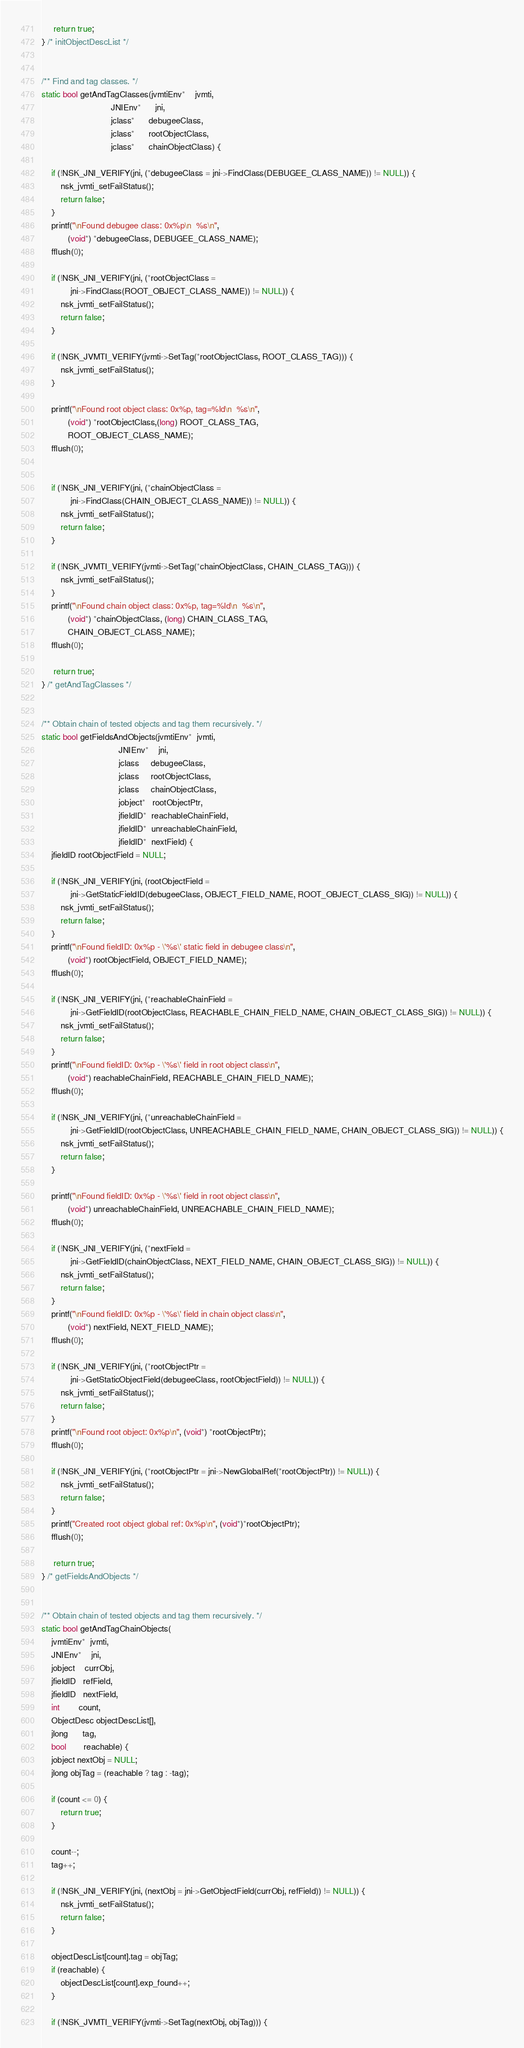Convert code to text. <code><loc_0><loc_0><loc_500><loc_500><_C++_>     return true;
} /* initObjectDescList */


/** Find and tag classes. */
static bool getAndTagClasses(jvmtiEnv*    jvmti,
                             JNIEnv*      jni,
                             jclass*      debugeeClass,
                             jclass*      rootObjectClass,
                             jclass*      chainObjectClass) {

    if (!NSK_JNI_VERIFY(jni, (*debugeeClass = jni->FindClass(DEBUGEE_CLASS_NAME)) != NULL)) {
        nsk_jvmti_setFailStatus();
        return false;
    }
    printf("\nFound debugee class: 0x%p\n  %s\n",
           (void*) *debugeeClass, DEBUGEE_CLASS_NAME);
    fflush(0);

    if (!NSK_JNI_VERIFY(jni, (*rootObjectClass =
            jni->FindClass(ROOT_OBJECT_CLASS_NAME)) != NULL)) {
        nsk_jvmti_setFailStatus();
        return false;
    }

    if (!NSK_JVMTI_VERIFY(jvmti->SetTag(*rootObjectClass, ROOT_CLASS_TAG))) {
        nsk_jvmti_setFailStatus();
    }

    printf("\nFound root object class: 0x%p, tag=%ld\n  %s\n",
           (void*) *rootObjectClass,(long) ROOT_CLASS_TAG,
           ROOT_OBJECT_CLASS_NAME);
    fflush(0);


    if (!NSK_JNI_VERIFY(jni, (*chainObjectClass =
            jni->FindClass(CHAIN_OBJECT_CLASS_NAME)) != NULL)) {
        nsk_jvmti_setFailStatus();
        return false;
    }

    if (!NSK_JVMTI_VERIFY(jvmti->SetTag(*chainObjectClass, CHAIN_CLASS_TAG))) {
        nsk_jvmti_setFailStatus();
    }
    printf("\nFound chain object class: 0x%p, tag=%ld\n  %s\n",
           (void*) *chainObjectClass, (long) CHAIN_CLASS_TAG,
           CHAIN_OBJECT_CLASS_NAME);
    fflush(0);

     return true;
} /* getAndTagClasses */


/** Obtain chain of tested objects and tag them recursively. */
static bool getFieldsAndObjects(jvmtiEnv*  jvmti,
                                JNIEnv*    jni,
                                jclass     debugeeClass,
                                jclass     rootObjectClass,
                                jclass     chainObjectClass,
                                jobject*   rootObjectPtr,
                                jfieldID*  reachableChainField,
                                jfieldID*  unreachableChainField,
                                jfieldID*  nextField) {
    jfieldID rootObjectField = NULL;

    if (!NSK_JNI_VERIFY(jni, (rootObjectField =
            jni->GetStaticFieldID(debugeeClass, OBJECT_FIELD_NAME, ROOT_OBJECT_CLASS_SIG)) != NULL)) {
        nsk_jvmti_setFailStatus();
        return false;
    }
    printf("\nFound fieldID: 0x%p - \'%s\' static field in debugee class\n",
           (void*) rootObjectField, OBJECT_FIELD_NAME);
    fflush(0);

    if (!NSK_JNI_VERIFY(jni, (*reachableChainField =
            jni->GetFieldID(rootObjectClass, REACHABLE_CHAIN_FIELD_NAME, CHAIN_OBJECT_CLASS_SIG)) != NULL)) {
        nsk_jvmti_setFailStatus();
        return false;
    }
    printf("\nFound fieldID: 0x%p - \'%s\' field in root object class\n",
           (void*) reachableChainField, REACHABLE_CHAIN_FIELD_NAME);
    fflush(0);

    if (!NSK_JNI_VERIFY(jni, (*unreachableChainField =
            jni->GetFieldID(rootObjectClass, UNREACHABLE_CHAIN_FIELD_NAME, CHAIN_OBJECT_CLASS_SIG)) != NULL)) {
        nsk_jvmti_setFailStatus();
        return false;
    }

    printf("\nFound fieldID: 0x%p - \'%s\' field in root object class\n",
           (void*) unreachableChainField, UNREACHABLE_CHAIN_FIELD_NAME);
    fflush(0);

    if (!NSK_JNI_VERIFY(jni, (*nextField =
            jni->GetFieldID(chainObjectClass, NEXT_FIELD_NAME, CHAIN_OBJECT_CLASS_SIG)) != NULL)) {
        nsk_jvmti_setFailStatus();
        return false;
    }
    printf("\nFound fieldID: 0x%p - \'%s\' field in chain object class\n",
           (void*) nextField, NEXT_FIELD_NAME);
    fflush(0);

    if (!NSK_JNI_VERIFY(jni, (*rootObjectPtr =
            jni->GetStaticObjectField(debugeeClass, rootObjectField)) != NULL)) {
        nsk_jvmti_setFailStatus();
        return false;
    }
    printf("\nFound root object: 0x%p\n", (void*) *rootObjectPtr);
    fflush(0);

    if (!NSK_JNI_VERIFY(jni, (*rootObjectPtr = jni->NewGlobalRef(*rootObjectPtr)) != NULL)) {
        nsk_jvmti_setFailStatus();
        return false;
    }
    printf("Created root object global ref: 0x%p\n", (void*)*rootObjectPtr);
    fflush(0);

     return true;
} /* getFieldsAndObjects */


/** Obtain chain of tested objects and tag them recursively. */
static bool getAndTagChainObjects(
    jvmtiEnv*  jvmti,
    JNIEnv*    jni,
    jobject    currObj,
    jfieldID   refField,
    jfieldID   nextField,
    int        count,
    ObjectDesc objectDescList[],
    jlong      tag,
    bool       reachable) {
    jobject nextObj = NULL;
    jlong objTag = (reachable ? tag : -tag);

    if (count <= 0) {
        return true;
    }

    count--;
    tag++;

    if (!NSK_JNI_VERIFY(jni, (nextObj = jni->GetObjectField(currObj, refField)) != NULL)) {
        nsk_jvmti_setFailStatus();
        return false;
    }

    objectDescList[count].tag = objTag;
    if (reachable) {
        objectDescList[count].exp_found++;
    }

    if (!NSK_JVMTI_VERIFY(jvmti->SetTag(nextObj, objTag))) {</code> 